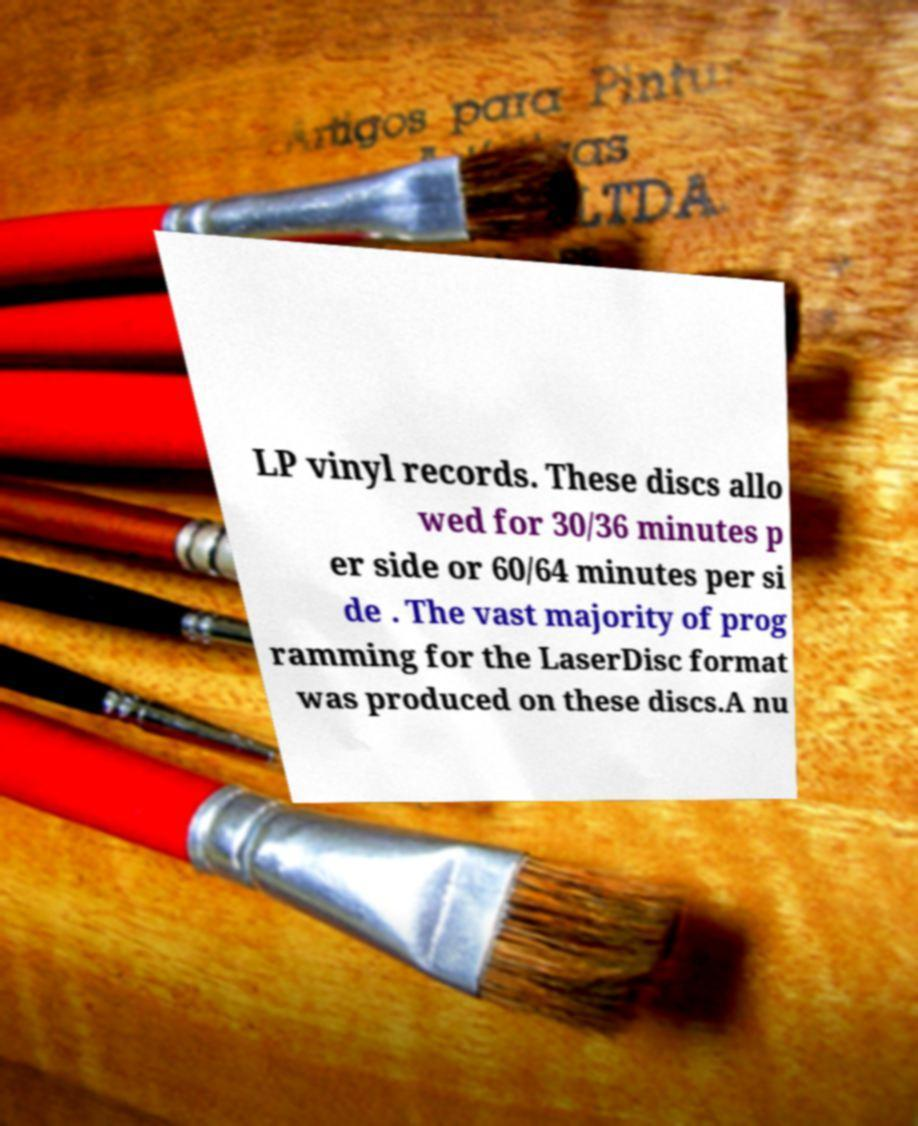There's text embedded in this image that I need extracted. Can you transcribe it verbatim? LP vinyl records. These discs allo wed for 30/36 minutes p er side or 60/64 minutes per si de . The vast majority of prog ramming for the LaserDisc format was produced on these discs.A nu 